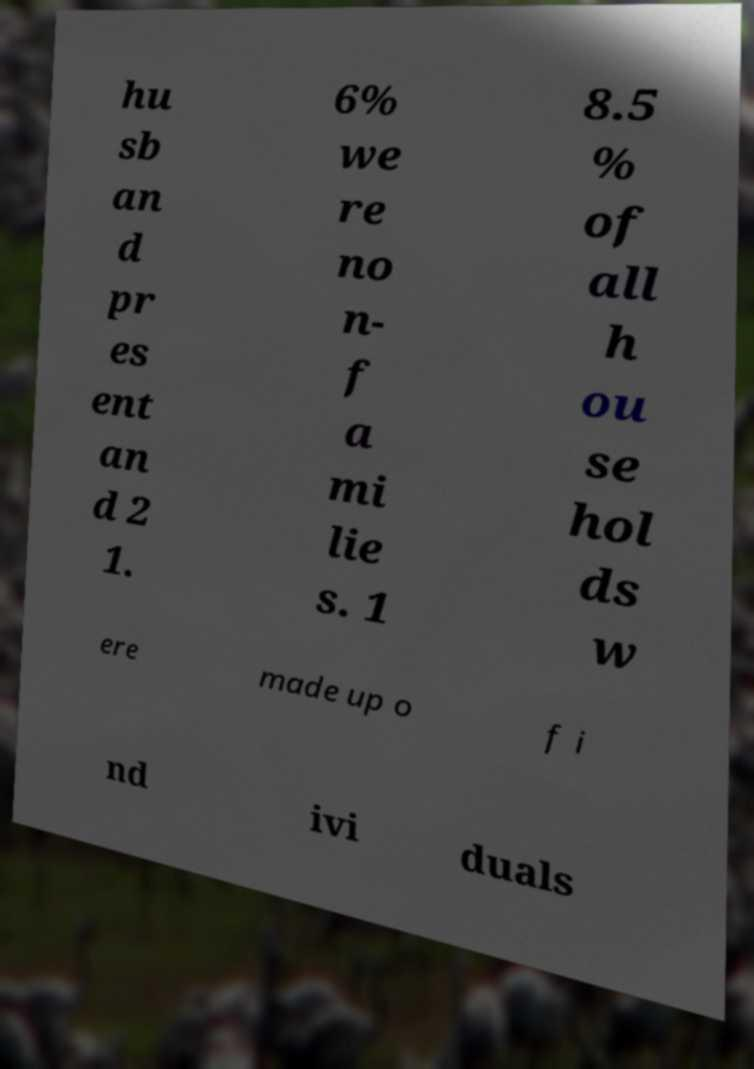Could you assist in decoding the text presented in this image and type it out clearly? hu sb an d pr es ent an d 2 1. 6% we re no n- f a mi lie s. 1 8.5 % of all h ou se hol ds w ere made up o f i nd ivi duals 